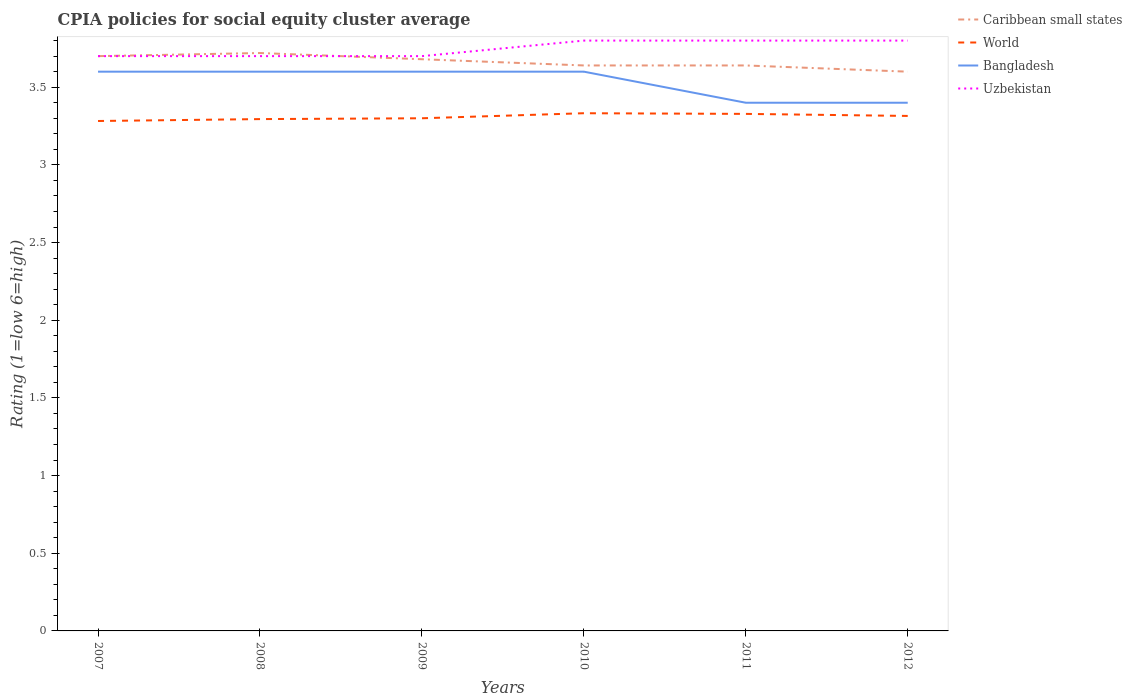Across all years, what is the maximum CPIA rating in World?
Your response must be concise. 3.28. What is the total CPIA rating in World in the graph?
Provide a succinct answer. -0.01. What is the difference between the highest and the second highest CPIA rating in World?
Give a very brief answer. 0.05. What is the difference between the highest and the lowest CPIA rating in Caribbean small states?
Ensure brevity in your answer.  3. How many lines are there?
Provide a succinct answer. 4. What is the difference between two consecutive major ticks on the Y-axis?
Make the answer very short. 0.5. Where does the legend appear in the graph?
Offer a very short reply. Top right. How many legend labels are there?
Give a very brief answer. 4. How are the legend labels stacked?
Provide a short and direct response. Vertical. What is the title of the graph?
Your answer should be compact. CPIA policies for social equity cluster average. What is the Rating (1=low 6=high) of World in 2007?
Provide a succinct answer. 3.28. What is the Rating (1=low 6=high) in Caribbean small states in 2008?
Ensure brevity in your answer.  3.72. What is the Rating (1=low 6=high) of World in 2008?
Your answer should be compact. 3.29. What is the Rating (1=low 6=high) of Uzbekistan in 2008?
Ensure brevity in your answer.  3.7. What is the Rating (1=low 6=high) in Caribbean small states in 2009?
Give a very brief answer. 3.68. What is the Rating (1=low 6=high) of World in 2009?
Your answer should be very brief. 3.3. What is the Rating (1=low 6=high) of Uzbekistan in 2009?
Offer a very short reply. 3.7. What is the Rating (1=low 6=high) of Caribbean small states in 2010?
Provide a short and direct response. 3.64. What is the Rating (1=low 6=high) of World in 2010?
Your response must be concise. 3.33. What is the Rating (1=low 6=high) in Caribbean small states in 2011?
Make the answer very short. 3.64. What is the Rating (1=low 6=high) in World in 2011?
Offer a very short reply. 3.33. What is the Rating (1=low 6=high) in Caribbean small states in 2012?
Provide a succinct answer. 3.6. What is the Rating (1=low 6=high) in World in 2012?
Keep it short and to the point. 3.31. What is the Rating (1=low 6=high) in Bangladesh in 2012?
Offer a very short reply. 3.4. What is the Rating (1=low 6=high) in Uzbekistan in 2012?
Keep it short and to the point. 3.8. Across all years, what is the maximum Rating (1=low 6=high) in Caribbean small states?
Ensure brevity in your answer.  3.72. Across all years, what is the maximum Rating (1=low 6=high) of World?
Make the answer very short. 3.33. Across all years, what is the minimum Rating (1=low 6=high) of World?
Ensure brevity in your answer.  3.28. Across all years, what is the minimum Rating (1=low 6=high) in Uzbekistan?
Keep it short and to the point. 3.7. What is the total Rating (1=low 6=high) in Caribbean small states in the graph?
Your answer should be very brief. 21.98. What is the total Rating (1=low 6=high) of World in the graph?
Ensure brevity in your answer.  19.85. What is the total Rating (1=low 6=high) in Bangladesh in the graph?
Keep it short and to the point. 21.2. What is the difference between the Rating (1=low 6=high) in Caribbean small states in 2007 and that in 2008?
Make the answer very short. -0.02. What is the difference between the Rating (1=low 6=high) in World in 2007 and that in 2008?
Provide a succinct answer. -0.01. What is the difference between the Rating (1=low 6=high) in Uzbekistan in 2007 and that in 2008?
Keep it short and to the point. 0. What is the difference between the Rating (1=low 6=high) in World in 2007 and that in 2009?
Ensure brevity in your answer.  -0.02. What is the difference between the Rating (1=low 6=high) in Bangladesh in 2007 and that in 2009?
Keep it short and to the point. 0. What is the difference between the Rating (1=low 6=high) of Caribbean small states in 2007 and that in 2010?
Give a very brief answer. 0.06. What is the difference between the Rating (1=low 6=high) of World in 2007 and that in 2010?
Provide a short and direct response. -0.05. What is the difference between the Rating (1=low 6=high) in Bangladesh in 2007 and that in 2010?
Your answer should be compact. 0. What is the difference between the Rating (1=low 6=high) in Uzbekistan in 2007 and that in 2010?
Provide a short and direct response. -0.1. What is the difference between the Rating (1=low 6=high) in World in 2007 and that in 2011?
Your answer should be compact. -0.05. What is the difference between the Rating (1=low 6=high) in Bangladesh in 2007 and that in 2011?
Provide a succinct answer. 0.2. What is the difference between the Rating (1=low 6=high) in Uzbekistan in 2007 and that in 2011?
Your answer should be very brief. -0.1. What is the difference between the Rating (1=low 6=high) of Caribbean small states in 2007 and that in 2012?
Offer a very short reply. 0.1. What is the difference between the Rating (1=low 6=high) in World in 2007 and that in 2012?
Provide a short and direct response. -0.03. What is the difference between the Rating (1=low 6=high) in Bangladesh in 2007 and that in 2012?
Ensure brevity in your answer.  0.2. What is the difference between the Rating (1=low 6=high) in Caribbean small states in 2008 and that in 2009?
Offer a terse response. 0.04. What is the difference between the Rating (1=low 6=high) in World in 2008 and that in 2009?
Keep it short and to the point. -0.01. What is the difference between the Rating (1=low 6=high) of Uzbekistan in 2008 and that in 2009?
Keep it short and to the point. 0. What is the difference between the Rating (1=low 6=high) of World in 2008 and that in 2010?
Keep it short and to the point. -0.04. What is the difference between the Rating (1=low 6=high) in Bangladesh in 2008 and that in 2010?
Keep it short and to the point. 0. What is the difference between the Rating (1=low 6=high) in Caribbean small states in 2008 and that in 2011?
Provide a succinct answer. 0.08. What is the difference between the Rating (1=low 6=high) in World in 2008 and that in 2011?
Keep it short and to the point. -0.03. What is the difference between the Rating (1=low 6=high) in Uzbekistan in 2008 and that in 2011?
Your answer should be very brief. -0.1. What is the difference between the Rating (1=low 6=high) of Caribbean small states in 2008 and that in 2012?
Make the answer very short. 0.12. What is the difference between the Rating (1=low 6=high) of World in 2008 and that in 2012?
Give a very brief answer. -0.02. What is the difference between the Rating (1=low 6=high) in Bangladesh in 2008 and that in 2012?
Offer a terse response. 0.2. What is the difference between the Rating (1=low 6=high) of Uzbekistan in 2008 and that in 2012?
Offer a very short reply. -0.1. What is the difference between the Rating (1=low 6=high) of Caribbean small states in 2009 and that in 2010?
Offer a terse response. 0.04. What is the difference between the Rating (1=low 6=high) in World in 2009 and that in 2010?
Ensure brevity in your answer.  -0.03. What is the difference between the Rating (1=low 6=high) of Bangladesh in 2009 and that in 2010?
Ensure brevity in your answer.  0. What is the difference between the Rating (1=low 6=high) in World in 2009 and that in 2011?
Your response must be concise. -0.03. What is the difference between the Rating (1=low 6=high) of Caribbean small states in 2009 and that in 2012?
Ensure brevity in your answer.  0.08. What is the difference between the Rating (1=low 6=high) in World in 2009 and that in 2012?
Give a very brief answer. -0.01. What is the difference between the Rating (1=low 6=high) of Bangladesh in 2009 and that in 2012?
Offer a very short reply. 0.2. What is the difference between the Rating (1=low 6=high) in World in 2010 and that in 2011?
Give a very brief answer. 0. What is the difference between the Rating (1=low 6=high) of Bangladesh in 2010 and that in 2011?
Your answer should be compact. 0.2. What is the difference between the Rating (1=low 6=high) of Uzbekistan in 2010 and that in 2011?
Offer a terse response. 0. What is the difference between the Rating (1=low 6=high) in World in 2010 and that in 2012?
Provide a succinct answer. 0.02. What is the difference between the Rating (1=low 6=high) in Bangladesh in 2010 and that in 2012?
Provide a succinct answer. 0.2. What is the difference between the Rating (1=low 6=high) in Caribbean small states in 2011 and that in 2012?
Your answer should be compact. 0.04. What is the difference between the Rating (1=low 6=high) of World in 2011 and that in 2012?
Your answer should be compact. 0.01. What is the difference between the Rating (1=low 6=high) of Bangladesh in 2011 and that in 2012?
Offer a terse response. 0. What is the difference between the Rating (1=low 6=high) of Caribbean small states in 2007 and the Rating (1=low 6=high) of World in 2008?
Provide a short and direct response. 0.41. What is the difference between the Rating (1=low 6=high) of World in 2007 and the Rating (1=low 6=high) of Bangladesh in 2008?
Give a very brief answer. -0.32. What is the difference between the Rating (1=low 6=high) in World in 2007 and the Rating (1=low 6=high) in Uzbekistan in 2008?
Offer a very short reply. -0.42. What is the difference between the Rating (1=low 6=high) in Caribbean small states in 2007 and the Rating (1=low 6=high) in Bangladesh in 2009?
Offer a terse response. 0.1. What is the difference between the Rating (1=low 6=high) of World in 2007 and the Rating (1=low 6=high) of Bangladesh in 2009?
Ensure brevity in your answer.  -0.32. What is the difference between the Rating (1=low 6=high) in World in 2007 and the Rating (1=low 6=high) in Uzbekistan in 2009?
Provide a succinct answer. -0.42. What is the difference between the Rating (1=low 6=high) of Bangladesh in 2007 and the Rating (1=low 6=high) of Uzbekistan in 2009?
Offer a very short reply. -0.1. What is the difference between the Rating (1=low 6=high) of Caribbean small states in 2007 and the Rating (1=low 6=high) of World in 2010?
Make the answer very short. 0.37. What is the difference between the Rating (1=low 6=high) of Caribbean small states in 2007 and the Rating (1=low 6=high) of Bangladesh in 2010?
Provide a short and direct response. 0.1. What is the difference between the Rating (1=low 6=high) of Caribbean small states in 2007 and the Rating (1=low 6=high) of Uzbekistan in 2010?
Provide a short and direct response. -0.1. What is the difference between the Rating (1=low 6=high) of World in 2007 and the Rating (1=low 6=high) of Bangladesh in 2010?
Give a very brief answer. -0.32. What is the difference between the Rating (1=low 6=high) in World in 2007 and the Rating (1=low 6=high) in Uzbekistan in 2010?
Give a very brief answer. -0.52. What is the difference between the Rating (1=low 6=high) of Bangladesh in 2007 and the Rating (1=low 6=high) of Uzbekistan in 2010?
Offer a very short reply. -0.2. What is the difference between the Rating (1=low 6=high) in Caribbean small states in 2007 and the Rating (1=low 6=high) in World in 2011?
Your response must be concise. 0.37. What is the difference between the Rating (1=low 6=high) in Caribbean small states in 2007 and the Rating (1=low 6=high) in Bangladesh in 2011?
Provide a succinct answer. 0.3. What is the difference between the Rating (1=low 6=high) of Caribbean small states in 2007 and the Rating (1=low 6=high) of Uzbekistan in 2011?
Provide a succinct answer. -0.1. What is the difference between the Rating (1=low 6=high) of World in 2007 and the Rating (1=low 6=high) of Bangladesh in 2011?
Provide a succinct answer. -0.12. What is the difference between the Rating (1=low 6=high) in World in 2007 and the Rating (1=low 6=high) in Uzbekistan in 2011?
Your answer should be very brief. -0.52. What is the difference between the Rating (1=low 6=high) in Bangladesh in 2007 and the Rating (1=low 6=high) in Uzbekistan in 2011?
Offer a very short reply. -0.2. What is the difference between the Rating (1=low 6=high) of Caribbean small states in 2007 and the Rating (1=low 6=high) of World in 2012?
Offer a terse response. 0.39. What is the difference between the Rating (1=low 6=high) in Caribbean small states in 2007 and the Rating (1=low 6=high) in Uzbekistan in 2012?
Make the answer very short. -0.1. What is the difference between the Rating (1=low 6=high) in World in 2007 and the Rating (1=low 6=high) in Bangladesh in 2012?
Keep it short and to the point. -0.12. What is the difference between the Rating (1=low 6=high) of World in 2007 and the Rating (1=low 6=high) of Uzbekistan in 2012?
Offer a terse response. -0.52. What is the difference between the Rating (1=low 6=high) in Bangladesh in 2007 and the Rating (1=low 6=high) in Uzbekistan in 2012?
Your answer should be very brief. -0.2. What is the difference between the Rating (1=low 6=high) of Caribbean small states in 2008 and the Rating (1=low 6=high) of World in 2009?
Offer a very short reply. 0.42. What is the difference between the Rating (1=low 6=high) in Caribbean small states in 2008 and the Rating (1=low 6=high) in Bangladesh in 2009?
Offer a terse response. 0.12. What is the difference between the Rating (1=low 6=high) of World in 2008 and the Rating (1=low 6=high) of Bangladesh in 2009?
Make the answer very short. -0.31. What is the difference between the Rating (1=low 6=high) in World in 2008 and the Rating (1=low 6=high) in Uzbekistan in 2009?
Your answer should be compact. -0.41. What is the difference between the Rating (1=low 6=high) of Caribbean small states in 2008 and the Rating (1=low 6=high) of World in 2010?
Make the answer very short. 0.39. What is the difference between the Rating (1=low 6=high) in Caribbean small states in 2008 and the Rating (1=low 6=high) in Bangladesh in 2010?
Provide a short and direct response. 0.12. What is the difference between the Rating (1=low 6=high) of Caribbean small states in 2008 and the Rating (1=low 6=high) of Uzbekistan in 2010?
Provide a succinct answer. -0.08. What is the difference between the Rating (1=low 6=high) in World in 2008 and the Rating (1=low 6=high) in Bangladesh in 2010?
Provide a succinct answer. -0.31. What is the difference between the Rating (1=low 6=high) of World in 2008 and the Rating (1=low 6=high) of Uzbekistan in 2010?
Your response must be concise. -0.51. What is the difference between the Rating (1=low 6=high) in Caribbean small states in 2008 and the Rating (1=low 6=high) in World in 2011?
Keep it short and to the point. 0.39. What is the difference between the Rating (1=low 6=high) in Caribbean small states in 2008 and the Rating (1=low 6=high) in Bangladesh in 2011?
Offer a very short reply. 0.32. What is the difference between the Rating (1=low 6=high) of Caribbean small states in 2008 and the Rating (1=low 6=high) of Uzbekistan in 2011?
Your response must be concise. -0.08. What is the difference between the Rating (1=low 6=high) in World in 2008 and the Rating (1=low 6=high) in Bangladesh in 2011?
Offer a terse response. -0.11. What is the difference between the Rating (1=low 6=high) in World in 2008 and the Rating (1=low 6=high) in Uzbekistan in 2011?
Ensure brevity in your answer.  -0.51. What is the difference between the Rating (1=low 6=high) of Bangladesh in 2008 and the Rating (1=low 6=high) of Uzbekistan in 2011?
Make the answer very short. -0.2. What is the difference between the Rating (1=low 6=high) in Caribbean small states in 2008 and the Rating (1=low 6=high) in World in 2012?
Keep it short and to the point. 0.41. What is the difference between the Rating (1=low 6=high) of Caribbean small states in 2008 and the Rating (1=low 6=high) of Bangladesh in 2012?
Provide a succinct answer. 0.32. What is the difference between the Rating (1=low 6=high) in Caribbean small states in 2008 and the Rating (1=low 6=high) in Uzbekistan in 2012?
Your answer should be compact. -0.08. What is the difference between the Rating (1=low 6=high) in World in 2008 and the Rating (1=low 6=high) in Bangladesh in 2012?
Offer a terse response. -0.11. What is the difference between the Rating (1=low 6=high) of World in 2008 and the Rating (1=low 6=high) of Uzbekistan in 2012?
Ensure brevity in your answer.  -0.51. What is the difference between the Rating (1=low 6=high) of Bangladesh in 2008 and the Rating (1=low 6=high) of Uzbekistan in 2012?
Give a very brief answer. -0.2. What is the difference between the Rating (1=low 6=high) of Caribbean small states in 2009 and the Rating (1=low 6=high) of World in 2010?
Make the answer very short. 0.35. What is the difference between the Rating (1=low 6=high) in Caribbean small states in 2009 and the Rating (1=low 6=high) in Bangladesh in 2010?
Give a very brief answer. 0.08. What is the difference between the Rating (1=low 6=high) in Caribbean small states in 2009 and the Rating (1=low 6=high) in Uzbekistan in 2010?
Your response must be concise. -0.12. What is the difference between the Rating (1=low 6=high) of World in 2009 and the Rating (1=low 6=high) of Bangladesh in 2010?
Provide a succinct answer. -0.3. What is the difference between the Rating (1=low 6=high) in World in 2009 and the Rating (1=low 6=high) in Uzbekistan in 2010?
Keep it short and to the point. -0.5. What is the difference between the Rating (1=low 6=high) in Bangladesh in 2009 and the Rating (1=low 6=high) in Uzbekistan in 2010?
Make the answer very short. -0.2. What is the difference between the Rating (1=low 6=high) in Caribbean small states in 2009 and the Rating (1=low 6=high) in World in 2011?
Keep it short and to the point. 0.35. What is the difference between the Rating (1=low 6=high) of Caribbean small states in 2009 and the Rating (1=low 6=high) of Bangladesh in 2011?
Provide a succinct answer. 0.28. What is the difference between the Rating (1=low 6=high) of Caribbean small states in 2009 and the Rating (1=low 6=high) of Uzbekistan in 2011?
Your answer should be very brief. -0.12. What is the difference between the Rating (1=low 6=high) of World in 2009 and the Rating (1=low 6=high) of Bangladesh in 2011?
Keep it short and to the point. -0.1. What is the difference between the Rating (1=low 6=high) in Caribbean small states in 2009 and the Rating (1=low 6=high) in World in 2012?
Your answer should be compact. 0.36. What is the difference between the Rating (1=low 6=high) in Caribbean small states in 2009 and the Rating (1=low 6=high) in Bangladesh in 2012?
Make the answer very short. 0.28. What is the difference between the Rating (1=low 6=high) in Caribbean small states in 2009 and the Rating (1=low 6=high) in Uzbekistan in 2012?
Your answer should be compact. -0.12. What is the difference between the Rating (1=low 6=high) of World in 2009 and the Rating (1=low 6=high) of Bangladesh in 2012?
Your answer should be compact. -0.1. What is the difference between the Rating (1=low 6=high) in World in 2009 and the Rating (1=low 6=high) in Uzbekistan in 2012?
Your response must be concise. -0.5. What is the difference between the Rating (1=low 6=high) in Bangladesh in 2009 and the Rating (1=low 6=high) in Uzbekistan in 2012?
Offer a terse response. -0.2. What is the difference between the Rating (1=low 6=high) in Caribbean small states in 2010 and the Rating (1=low 6=high) in World in 2011?
Your answer should be very brief. 0.31. What is the difference between the Rating (1=low 6=high) in Caribbean small states in 2010 and the Rating (1=low 6=high) in Bangladesh in 2011?
Make the answer very short. 0.24. What is the difference between the Rating (1=low 6=high) in Caribbean small states in 2010 and the Rating (1=low 6=high) in Uzbekistan in 2011?
Provide a succinct answer. -0.16. What is the difference between the Rating (1=low 6=high) of World in 2010 and the Rating (1=low 6=high) of Bangladesh in 2011?
Keep it short and to the point. -0.07. What is the difference between the Rating (1=low 6=high) of World in 2010 and the Rating (1=low 6=high) of Uzbekistan in 2011?
Give a very brief answer. -0.47. What is the difference between the Rating (1=low 6=high) in Caribbean small states in 2010 and the Rating (1=low 6=high) in World in 2012?
Ensure brevity in your answer.  0.33. What is the difference between the Rating (1=low 6=high) in Caribbean small states in 2010 and the Rating (1=low 6=high) in Bangladesh in 2012?
Ensure brevity in your answer.  0.24. What is the difference between the Rating (1=low 6=high) of Caribbean small states in 2010 and the Rating (1=low 6=high) of Uzbekistan in 2012?
Keep it short and to the point. -0.16. What is the difference between the Rating (1=low 6=high) of World in 2010 and the Rating (1=low 6=high) of Bangladesh in 2012?
Ensure brevity in your answer.  -0.07. What is the difference between the Rating (1=low 6=high) of World in 2010 and the Rating (1=low 6=high) of Uzbekistan in 2012?
Your answer should be very brief. -0.47. What is the difference between the Rating (1=low 6=high) of Bangladesh in 2010 and the Rating (1=low 6=high) of Uzbekistan in 2012?
Keep it short and to the point. -0.2. What is the difference between the Rating (1=low 6=high) of Caribbean small states in 2011 and the Rating (1=low 6=high) of World in 2012?
Your response must be concise. 0.33. What is the difference between the Rating (1=low 6=high) of Caribbean small states in 2011 and the Rating (1=low 6=high) of Bangladesh in 2012?
Provide a short and direct response. 0.24. What is the difference between the Rating (1=low 6=high) in Caribbean small states in 2011 and the Rating (1=low 6=high) in Uzbekistan in 2012?
Provide a succinct answer. -0.16. What is the difference between the Rating (1=low 6=high) of World in 2011 and the Rating (1=low 6=high) of Bangladesh in 2012?
Your answer should be compact. -0.07. What is the difference between the Rating (1=low 6=high) in World in 2011 and the Rating (1=low 6=high) in Uzbekistan in 2012?
Provide a short and direct response. -0.47. What is the average Rating (1=low 6=high) in Caribbean small states per year?
Give a very brief answer. 3.66. What is the average Rating (1=low 6=high) in World per year?
Your answer should be very brief. 3.31. What is the average Rating (1=low 6=high) in Bangladesh per year?
Provide a short and direct response. 3.53. What is the average Rating (1=low 6=high) of Uzbekistan per year?
Your response must be concise. 3.75. In the year 2007, what is the difference between the Rating (1=low 6=high) in Caribbean small states and Rating (1=low 6=high) in World?
Ensure brevity in your answer.  0.42. In the year 2007, what is the difference between the Rating (1=low 6=high) in World and Rating (1=low 6=high) in Bangladesh?
Your answer should be compact. -0.32. In the year 2007, what is the difference between the Rating (1=low 6=high) of World and Rating (1=low 6=high) of Uzbekistan?
Offer a terse response. -0.42. In the year 2008, what is the difference between the Rating (1=low 6=high) in Caribbean small states and Rating (1=low 6=high) in World?
Your response must be concise. 0.43. In the year 2008, what is the difference between the Rating (1=low 6=high) of Caribbean small states and Rating (1=low 6=high) of Bangladesh?
Offer a very short reply. 0.12. In the year 2008, what is the difference between the Rating (1=low 6=high) of World and Rating (1=low 6=high) of Bangladesh?
Make the answer very short. -0.31. In the year 2008, what is the difference between the Rating (1=low 6=high) in World and Rating (1=low 6=high) in Uzbekistan?
Your answer should be very brief. -0.41. In the year 2009, what is the difference between the Rating (1=low 6=high) in Caribbean small states and Rating (1=low 6=high) in World?
Provide a short and direct response. 0.38. In the year 2009, what is the difference between the Rating (1=low 6=high) in Caribbean small states and Rating (1=low 6=high) in Bangladesh?
Give a very brief answer. 0.08. In the year 2009, what is the difference between the Rating (1=low 6=high) of Caribbean small states and Rating (1=low 6=high) of Uzbekistan?
Provide a succinct answer. -0.02. In the year 2010, what is the difference between the Rating (1=low 6=high) in Caribbean small states and Rating (1=low 6=high) in World?
Make the answer very short. 0.31. In the year 2010, what is the difference between the Rating (1=low 6=high) of Caribbean small states and Rating (1=low 6=high) of Uzbekistan?
Give a very brief answer. -0.16. In the year 2010, what is the difference between the Rating (1=low 6=high) of World and Rating (1=low 6=high) of Bangladesh?
Keep it short and to the point. -0.27. In the year 2010, what is the difference between the Rating (1=low 6=high) of World and Rating (1=low 6=high) of Uzbekistan?
Offer a very short reply. -0.47. In the year 2010, what is the difference between the Rating (1=low 6=high) of Bangladesh and Rating (1=low 6=high) of Uzbekistan?
Make the answer very short. -0.2. In the year 2011, what is the difference between the Rating (1=low 6=high) in Caribbean small states and Rating (1=low 6=high) in World?
Ensure brevity in your answer.  0.31. In the year 2011, what is the difference between the Rating (1=low 6=high) in Caribbean small states and Rating (1=low 6=high) in Bangladesh?
Your answer should be very brief. 0.24. In the year 2011, what is the difference between the Rating (1=low 6=high) of Caribbean small states and Rating (1=low 6=high) of Uzbekistan?
Your answer should be very brief. -0.16. In the year 2011, what is the difference between the Rating (1=low 6=high) in World and Rating (1=low 6=high) in Bangladesh?
Offer a terse response. -0.07. In the year 2011, what is the difference between the Rating (1=low 6=high) in World and Rating (1=low 6=high) in Uzbekistan?
Offer a terse response. -0.47. In the year 2011, what is the difference between the Rating (1=low 6=high) of Bangladesh and Rating (1=low 6=high) of Uzbekistan?
Your answer should be compact. -0.4. In the year 2012, what is the difference between the Rating (1=low 6=high) of Caribbean small states and Rating (1=low 6=high) of World?
Provide a succinct answer. 0.28. In the year 2012, what is the difference between the Rating (1=low 6=high) of Caribbean small states and Rating (1=low 6=high) of Bangladesh?
Make the answer very short. 0.2. In the year 2012, what is the difference between the Rating (1=low 6=high) of World and Rating (1=low 6=high) of Bangladesh?
Make the answer very short. -0.09. In the year 2012, what is the difference between the Rating (1=low 6=high) of World and Rating (1=low 6=high) of Uzbekistan?
Offer a terse response. -0.48. In the year 2012, what is the difference between the Rating (1=low 6=high) in Bangladesh and Rating (1=low 6=high) in Uzbekistan?
Offer a terse response. -0.4. What is the ratio of the Rating (1=low 6=high) of World in 2007 to that in 2008?
Make the answer very short. 1. What is the ratio of the Rating (1=low 6=high) in Bangladesh in 2007 to that in 2008?
Offer a very short reply. 1. What is the ratio of the Rating (1=low 6=high) in Uzbekistan in 2007 to that in 2008?
Make the answer very short. 1. What is the ratio of the Rating (1=low 6=high) in Caribbean small states in 2007 to that in 2009?
Give a very brief answer. 1.01. What is the ratio of the Rating (1=low 6=high) in Bangladesh in 2007 to that in 2009?
Your response must be concise. 1. What is the ratio of the Rating (1=low 6=high) in Caribbean small states in 2007 to that in 2010?
Give a very brief answer. 1.02. What is the ratio of the Rating (1=low 6=high) of Bangladesh in 2007 to that in 2010?
Keep it short and to the point. 1. What is the ratio of the Rating (1=low 6=high) in Uzbekistan in 2007 to that in 2010?
Ensure brevity in your answer.  0.97. What is the ratio of the Rating (1=low 6=high) in Caribbean small states in 2007 to that in 2011?
Keep it short and to the point. 1.02. What is the ratio of the Rating (1=low 6=high) in World in 2007 to that in 2011?
Give a very brief answer. 0.99. What is the ratio of the Rating (1=low 6=high) of Bangladesh in 2007 to that in 2011?
Offer a very short reply. 1.06. What is the ratio of the Rating (1=low 6=high) of Uzbekistan in 2007 to that in 2011?
Your answer should be very brief. 0.97. What is the ratio of the Rating (1=low 6=high) in Caribbean small states in 2007 to that in 2012?
Provide a short and direct response. 1.03. What is the ratio of the Rating (1=low 6=high) in World in 2007 to that in 2012?
Ensure brevity in your answer.  0.99. What is the ratio of the Rating (1=low 6=high) of Bangladesh in 2007 to that in 2012?
Provide a succinct answer. 1.06. What is the ratio of the Rating (1=low 6=high) in Uzbekistan in 2007 to that in 2012?
Provide a succinct answer. 0.97. What is the ratio of the Rating (1=low 6=high) in Caribbean small states in 2008 to that in 2009?
Provide a short and direct response. 1.01. What is the ratio of the Rating (1=low 6=high) in Bangladesh in 2008 to that in 2009?
Make the answer very short. 1. What is the ratio of the Rating (1=low 6=high) in World in 2008 to that in 2010?
Your answer should be very brief. 0.99. What is the ratio of the Rating (1=low 6=high) in Uzbekistan in 2008 to that in 2010?
Provide a succinct answer. 0.97. What is the ratio of the Rating (1=low 6=high) in World in 2008 to that in 2011?
Provide a short and direct response. 0.99. What is the ratio of the Rating (1=low 6=high) of Bangladesh in 2008 to that in 2011?
Provide a short and direct response. 1.06. What is the ratio of the Rating (1=low 6=high) in Uzbekistan in 2008 to that in 2011?
Offer a very short reply. 0.97. What is the ratio of the Rating (1=low 6=high) of World in 2008 to that in 2012?
Give a very brief answer. 0.99. What is the ratio of the Rating (1=low 6=high) of Bangladesh in 2008 to that in 2012?
Provide a short and direct response. 1.06. What is the ratio of the Rating (1=low 6=high) in Uzbekistan in 2008 to that in 2012?
Offer a terse response. 0.97. What is the ratio of the Rating (1=low 6=high) in Caribbean small states in 2009 to that in 2010?
Keep it short and to the point. 1.01. What is the ratio of the Rating (1=low 6=high) of World in 2009 to that in 2010?
Give a very brief answer. 0.99. What is the ratio of the Rating (1=low 6=high) of Uzbekistan in 2009 to that in 2010?
Provide a short and direct response. 0.97. What is the ratio of the Rating (1=low 6=high) of World in 2009 to that in 2011?
Provide a succinct answer. 0.99. What is the ratio of the Rating (1=low 6=high) of Bangladesh in 2009 to that in 2011?
Your answer should be very brief. 1.06. What is the ratio of the Rating (1=low 6=high) of Uzbekistan in 2009 to that in 2011?
Provide a succinct answer. 0.97. What is the ratio of the Rating (1=low 6=high) in Caribbean small states in 2009 to that in 2012?
Your response must be concise. 1.02. What is the ratio of the Rating (1=low 6=high) of Bangladesh in 2009 to that in 2012?
Ensure brevity in your answer.  1.06. What is the ratio of the Rating (1=low 6=high) of Uzbekistan in 2009 to that in 2012?
Give a very brief answer. 0.97. What is the ratio of the Rating (1=low 6=high) of Caribbean small states in 2010 to that in 2011?
Your answer should be very brief. 1. What is the ratio of the Rating (1=low 6=high) of Bangladesh in 2010 to that in 2011?
Keep it short and to the point. 1.06. What is the ratio of the Rating (1=low 6=high) of Uzbekistan in 2010 to that in 2011?
Provide a short and direct response. 1. What is the ratio of the Rating (1=low 6=high) in Caribbean small states in 2010 to that in 2012?
Your answer should be compact. 1.01. What is the ratio of the Rating (1=low 6=high) in World in 2010 to that in 2012?
Keep it short and to the point. 1.01. What is the ratio of the Rating (1=low 6=high) in Bangladesh in 2010 to that in 2012?
Ensure brevity in your answer.  1.06. What is the ratio of the Rating (1=low 6=high) of Caribbean small states in 2011 to that in 2012?
Offer a very short reply. 1.01. What is the ratio of the Rating (1=low 6=high) of Bangladesh in 2011 to that in 2012?
Keep it short and to the point. 1. What is the difference between the highest and the second highest Rating (1=low 6=high) of World?
Your response must be concise. 0. What is the difference between the highest and the second highest Rating (1=low 6=high) of Bangladesh?
Keep it short and to the point. 0. What is the difference between the highest and the second highest Rating (1=low 6=high) of Uzbekistan?
Provide a succinct answer. 0. What is the difference between the highest and the lowest Rating (1=low 6=high) of Caribbean small states?
Keep it short and to the point. 0.12. What is the difference between the highest and the lowest Rating (1=low 6=high) of World?
Provide a succinct answer. 0.05. What is the difference between the highest and the lowest Rating (1=low 6=high) in Bangladesh?
Ensure brevity in your answer.  0.2. What is the difference between the highest and the lowest Rating (1=low 6=high) of Uzbekistan?
Provide a succinct answer. 0.1. 